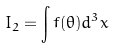Convert formula to latex. <formula><loc_0><loc_0><loc_500><loc_500>I _ { 2 } = \int f ( \theta ) d ^ { 3 } x</formula> 